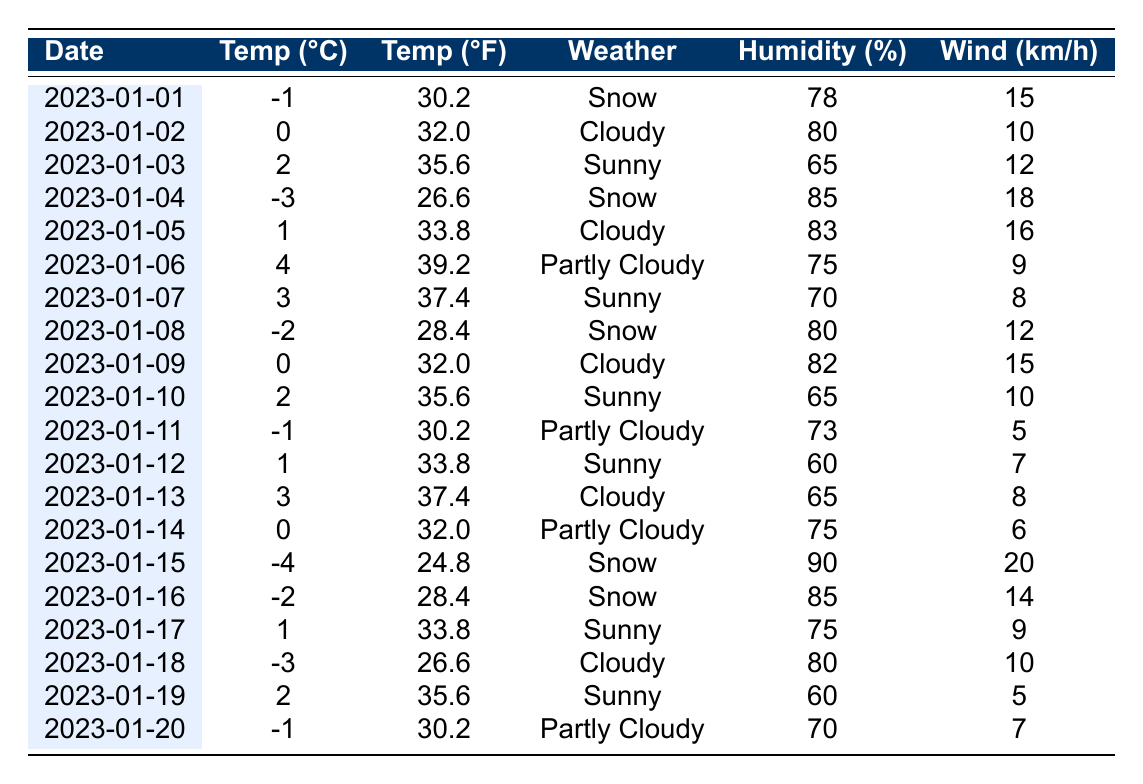What was the temperature on January 1, 2023? The table shows that the temperature on January 1, 2023, was -1°C.
Answer: -1°C How many days experienced snow in the first 20 days of January 2023? By checking the weather condition for each day, I found that there were 5 days (January 1, 4, 8, 15, and 16) with snow.
Answer: 5 days What is the highest temperature recorded in January 2023? Reviewing the temperature values, the highest temperature recorded was 4°C on January 6, 2023.
Answer: 4°C What was the average humidity percentage over the first 20 days of January 2023? The humidity percentages for the first 20 days total up to 80 + 80 + 65 + 85 + 83 + 75 + 70 + 80 + 82 + 65 + 73 + 60 + 65 + 75 + 90 + 85 + 75 + 80 + 60 + 70 = 1450. Dividing this sum by 20 days gives an average of 72.5%.
Answer: 72.5% On which day was the temperature below freezing and not snowing? Looking through the table, January 12 (1°C), January 14 (0°C), and January 20 (-1°C) are the only dates near freezing not marked with snow, however, among these, January 20 is the one not snowing because both January 12 and January 14 are part of a cloudy weather condition.
Answer: January 20 Which day had the lowest wind speed? The minimum wind speed recorded was 5 km/h on January 11, 2023.
Answer: 5 km/h Is it true that more than half of the recorded days had a humidity percentage above 75%? By counting the days with humidity above 75%, I found 11 days out of 20 had a humidity percentage above that threshold, which is more than half.
Answer: Yes What is the difference in temperature between the highest and lowest temperature recorded within the table? The highest temperature was 4°C (January 6) and the lowest was -4°C (January 15). The difference is 4 - (-4) = 8°C.
Answer: 8°C How many sunny days were there in January 2023? There were 6 sunny days (January 3, 6, 7, 10, 12, and 19) in the first 20 days of January 2023.
Answer: 6 sunny days On which day was the humidity at its peak? The maximum humidity reading was 90% on January 15, 2023.
Answer: January 15 